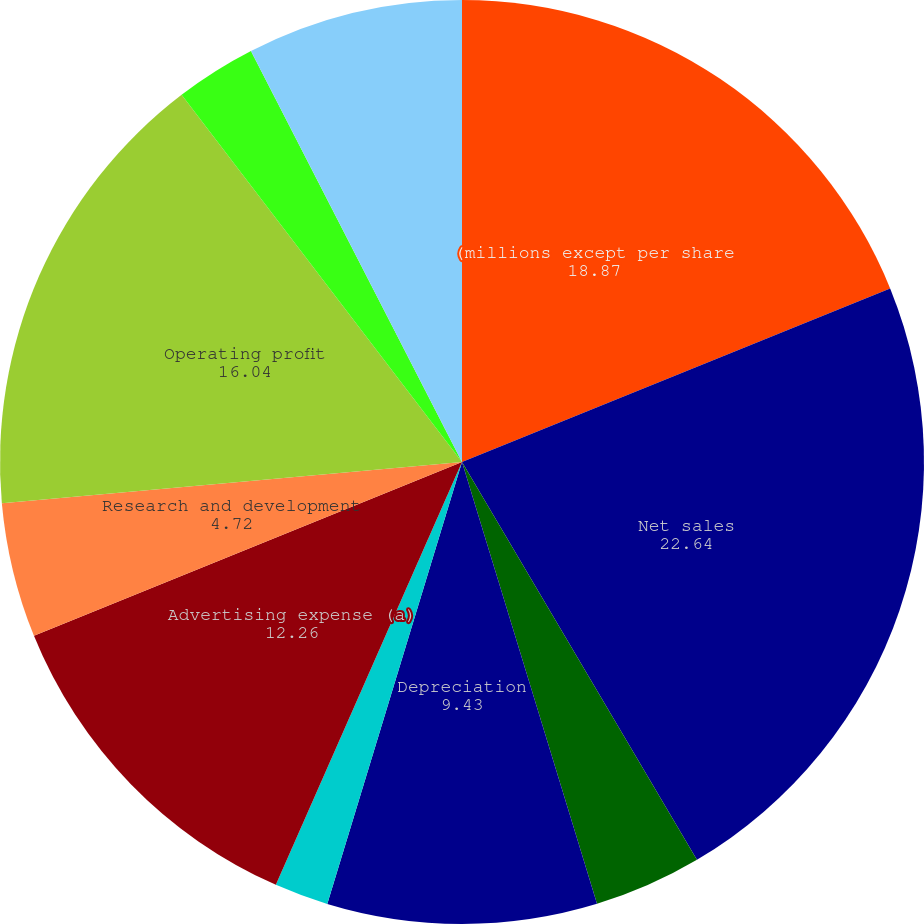<chart> <loc_0><loc_0><loc_500><loc_500><pie_chart><fcel>(millions except per share<fcel>Net sales<fcel>Gross profit as a of net sales<fcel>Depreciation<fcel>Amortization<fcel>Advertising expense (a)<fcel>Research and development<fcel>Operating profit<fcel>Operating profit as a of net<fcel>Interest expense<nl><fcel>18.87%<fcel>22.64%<fcel>3.77%<fcel>9.43%<fcel>1.89%<fcel>12.26%<fcel>4.72%<fcel>16.04%<fcel>2.83%<fcel>7.55%<nl></chart> 